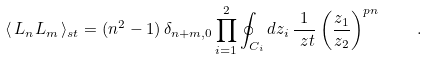<formula> <loc_0><loc_0><loc_500><loc_500>\langle \, L _ { n } L _ { m } \, \rangle _ { s t } = ( n ^ { 2 } - 1 ) \, \delta _ { n + m , 0 } \prod _ { i = 1 } ^ { 2 } \oint _ { C _ { i } } d z _ { i } \, \frac { 1 } { \ z t } \left ( \frac { z _ { 1 } } { z _ { 2 } } \right ) ^ { p n } \quad .</formula> 